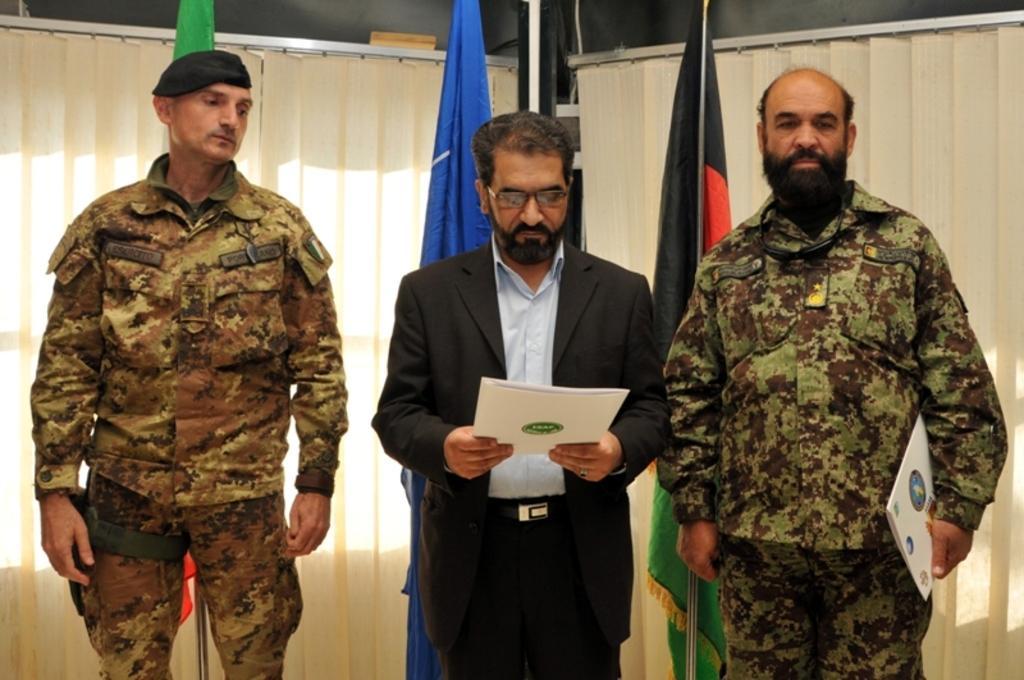How would you summarize this image in a sentence or two? In this image we can see three people, one of them is holding a book, there are flags behind them, also we can see the wall, and curtains. 